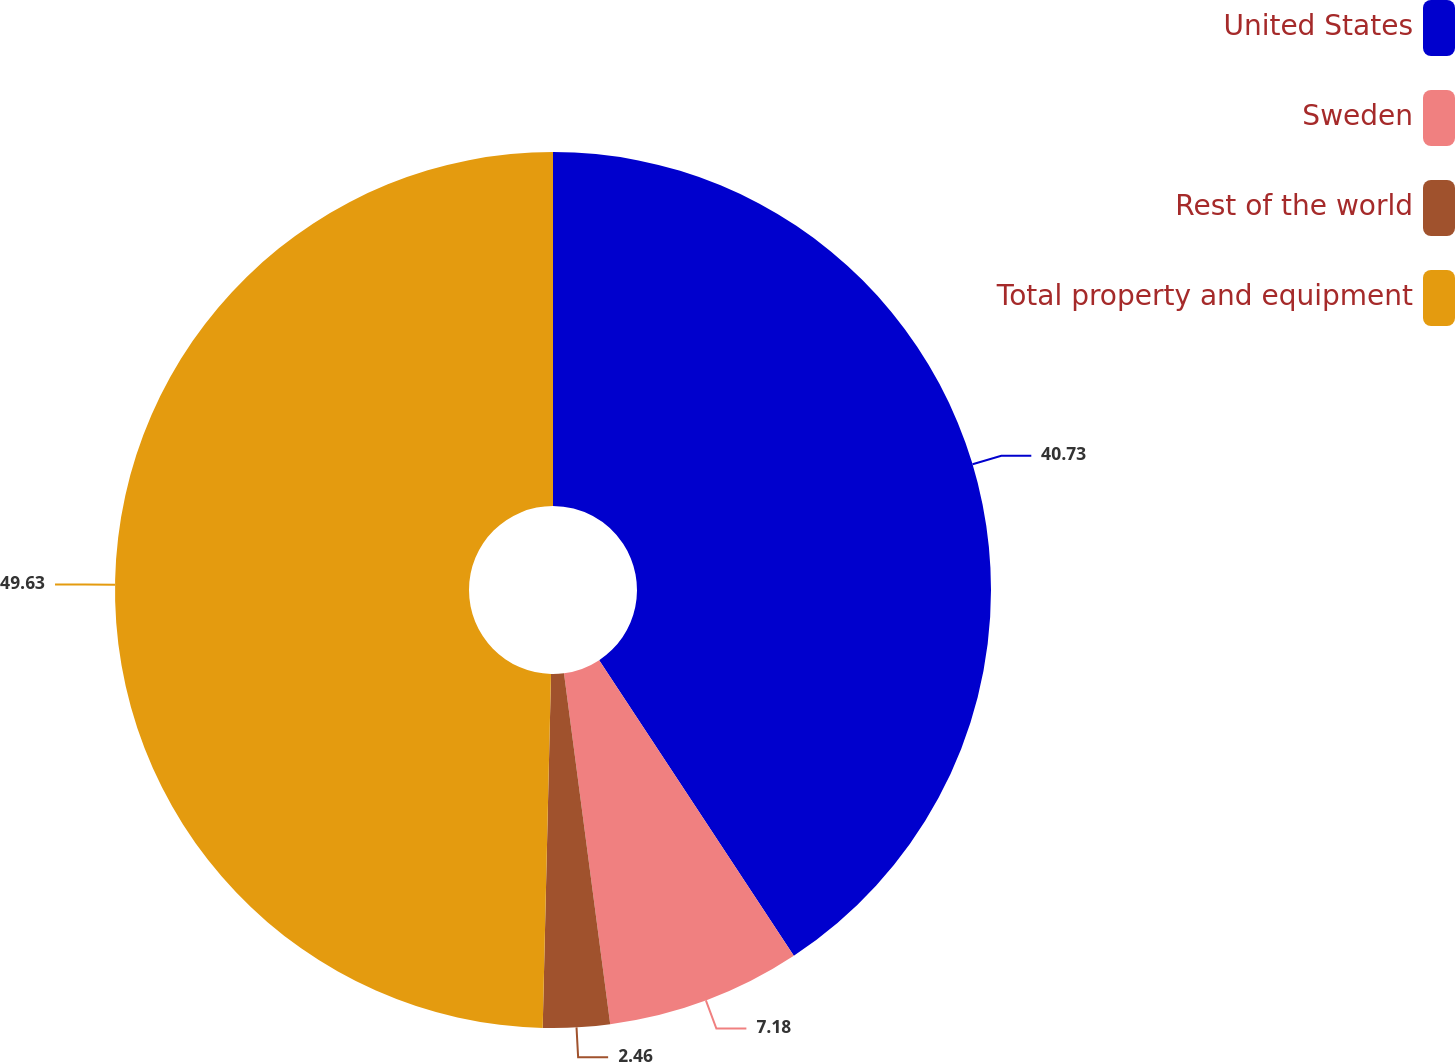Convert chart to OTSL. <chart><loc_0><loc_0><loc_500><loc_500><pie_chart><fcel>United States<fcel>Sweden<fcel>Rest of the world<fcel>Total property and equipment<nl><fcel>40.73%<fcel>7.18%<fcel>2.46%<fcel>49.62%<nl></chart> 